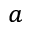Convert formula to latex. <formula><loc_0><loc_0><loc_500><loc_500>^ { a }</formula> 